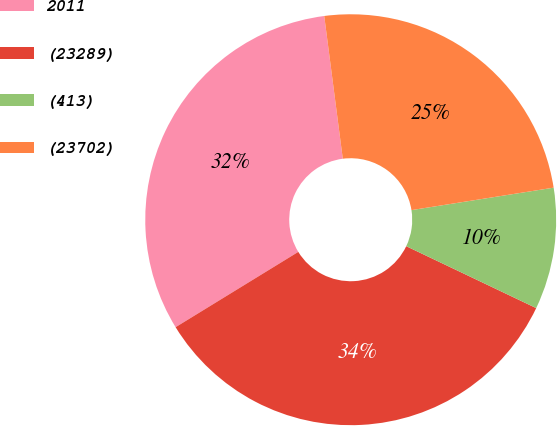<chart> <loc_0><loc_0><loc_500><loc_500><pie_chart><fcel>2011<fcel>(23289)<fcel>(413)<fcel>(23702)<nl><fcel>31.7%<fcel>34.16%<fcel>9.57%<fcel>24.56%<nl></chart> 